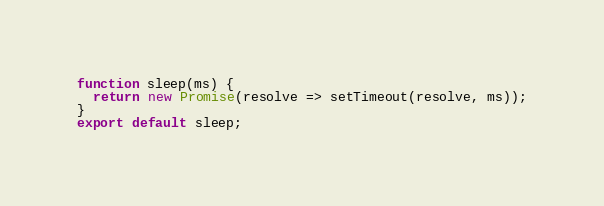Convert code to text. <code><loc_0><loc_0><loc_500><loc_500><_JavaScript_>function sleep(ms) {
  return new Promise(resolve => setTimeout(resolve, ms));
}
export default sleep;
</code> 